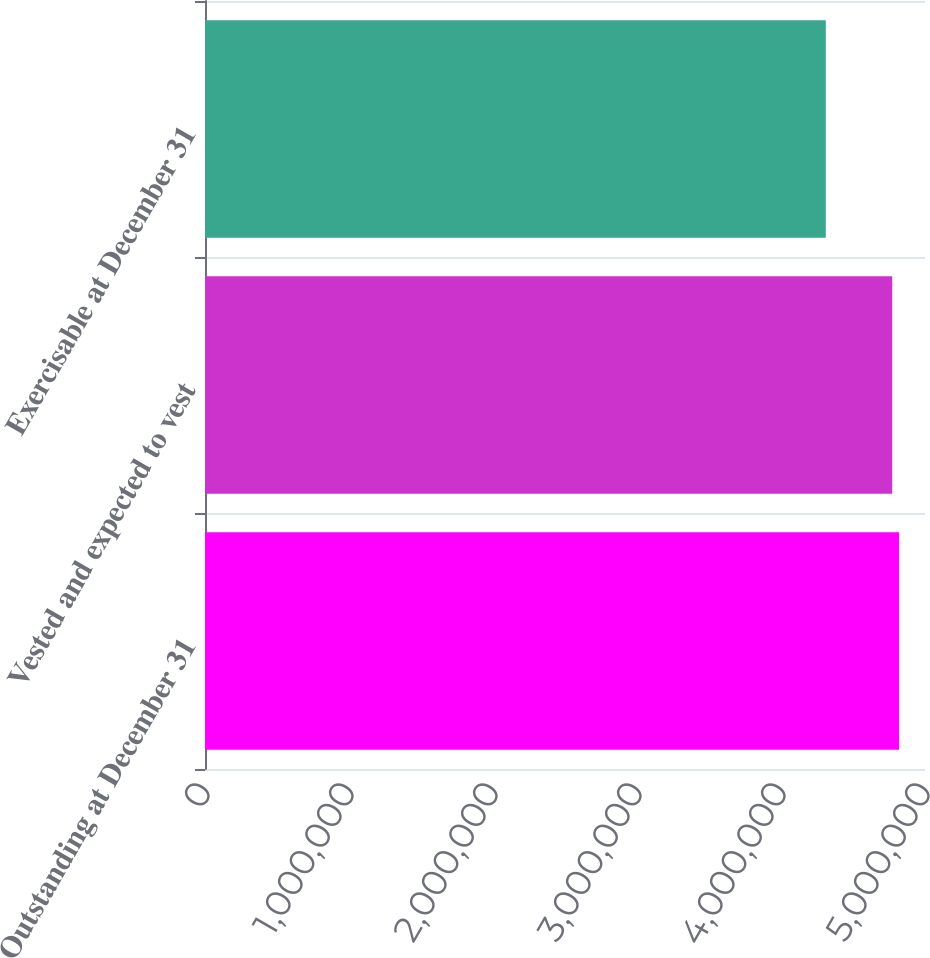<chart> <loc_0><loc_0><loc_500><loc_500><bar_chart><fcel>Outstanding at December 31<fcel>Vested and expected to vest<fcel>Exercisable at December 31<nl><fcel>4.82004e+06<fcel>4.77253e+06<fcel>4.31118e+06<nl></chart> 